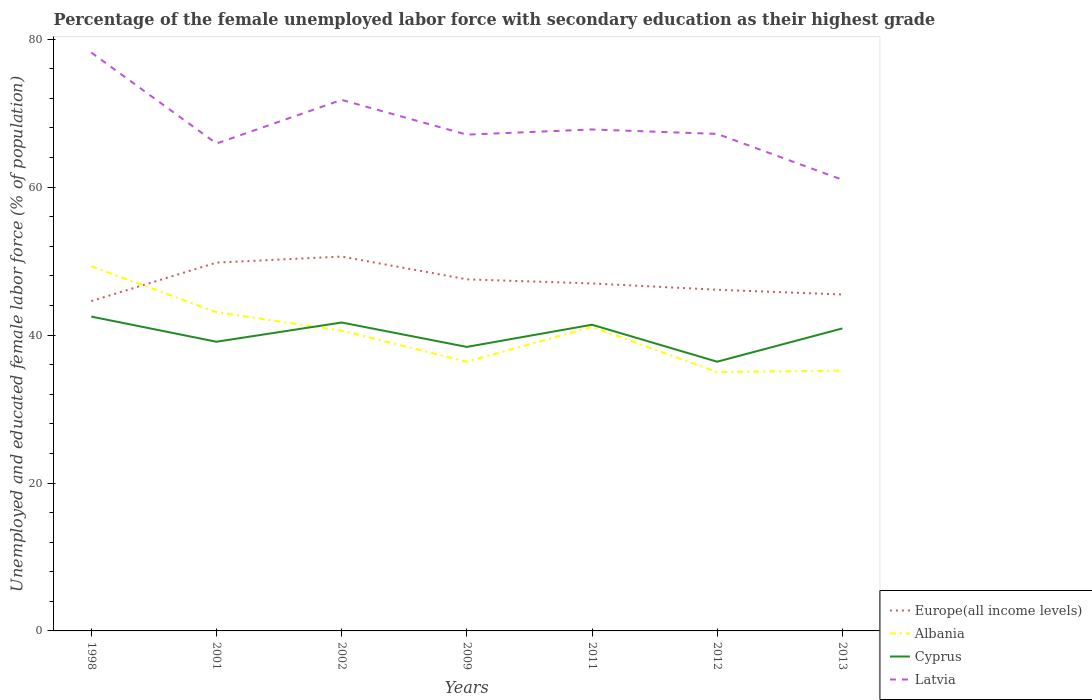How many different coloured lines are there?
Give a very brief answer. 4. Does the line corresponding to Cyprus intersect with the line corresponding to Latvia?
Keep it short and to the point. No. Is the number of lines equal to the number of legend labels?
Offer a terse response. Yes. Across all years, what is the maximum percentage of the unemployed female labor force with secondary education in Europe(all income levels)?
Offer a terse response. 44.6. What is the total percentage of the unemployed female labor force with secondary education in Albania in the graph?
Make the answer very short. 8.1. What is the difference between the highest and the second highest percentage of the unemployed female labor force with secondary education in Latvia?
Make the answer very short. 17.2. What is the difference between the highest and the lowest percentage of the unemployed female labor force with secondary education in Latvia?
Provide a short and direct response. 2. Does the graph contain grids?
Your answer should be very brief. No. How many legend labels are there?
Ensure brevity in your answer.  4. How are the legend labels stacked?
Your answer should be very brief. Vertical. What is the title of the graph?
Provide a short and direct response. Percentage of the female unemployed labor force with secondary education as their highest grade. Does "San Marino" appear as one of the legend labels in the graph?
Your answer should be compact. No. What is the label or title of the Y-axis?
Your response must be concise. Unemployed and educated female labor force (% of population). What is the Unemployed and educated female labor force (% of population) of Europe(all income levels) in 1998?
Your response must be concise. 44.6. What is the Unemployed and educated female labor force (% of population) of Albania in 1998?
Give a very brief answer. 49.3. What is the Unemployed and educated female labor force (% of population) of Cyprus in 1998?
Your answer should be compact. 42.5. What is the Unemployed and educated female labor force (% of population) of Latvia in 1998?
Provide a short and direct response. 78.2. What is the Unemployed and educated female labor force (% of population) in Europe(all income levels) in 2001?
Provide a short and direct response. 49.8. What is the Unemployed and educated female labor force (% of population) in Albania in 2001?
Keep it short and to the point. 43.1. What is the Unemployed and educated female labor force (% of population) in Cyprus in 2001?
Give a very brief answer. 39.1. What is the Unemployed and educated female labor force (% of population) in Latvia in 2001?
Provide a succinct answer. 65.9. What is the Unemployed and educated female labor force (% of population) in Europe(all income levels) in 2002?
Provide a short and direct response. 50.62. What is the Unemployed and educated female labor force (% of population) in Albania in 2002?
Make the answer very short. 40.6. What is the Unemployed and educated female labor force (% of population) of Cyprus in 2002?
Offer a very short reply. 41.7. What is the Unemployed and educated female labor force (% of population) in Latvia in 2002?
Ensure brevity in your answer.  71.8. What is the Unemployed and educated female labor force (% of population) of Europe(all income levels) in 2009?
Your response must be concise. 47.54. What is the Unemployed and educated female labor force (% of population) in Albania in 2009?
Give a very brief answer. 36.4. What is the Unemployed and educated female labor force (% of population) of Cyprus in 2009?
Provide a succinct answer. 38.4. What is the Unemployed and educated female labor force (% of population) in Latvia in 2009?
Give a very brief answer. 67.1. What is the Unemployed and educated female labor force (% of population) in Europe(all income levels) in 2011?
Your answer should be compact. 46.98. What is the Unemployed and educated female labor force (% of population) in Albania in 2011?
Your answer should be compact. 41.1. What is the Unemployed and educated female labor force (% of population) of Cyprus in 2011?
Offer a terse response. 41.4. What is the Unemployed and educated female labor force (% of population) of Latvia in 2011?
Keep it short and to the point. 67.8. What is the Unemployed and educated female labor force (% of population) in Europe(all income levels) in 2012?
Keep it short and to the point. 46.13. What is the Unemployed and educated female labor force (% of population) in Albania in 2012?
Offer a very short reply. 35. What is the Unemployed and educated female labor force (% of population) of Cyprus in 2012?
Provide a succinct answer. 36.4. What is the Unemployed and educated female labor force (% of population) of Latvia in 2012?
Your answer should be compact. 67.2. What is the Unemployed and educated female labor force (% of population) of Europe(all income levels) in 2013?
Your answer should be very brief. 45.49. What is the Unemployed and educated female labor force (% of population) of Albania in 2013?
Offer a terse response. 35.2. What is the Unemployed and educated female labor force (% of population) of Cyprus in 2013?
Your response must be concise. 40.9. Across all years, what is the maximum Unemployed and educated female labor force (% of population) of Europe(all income levels)?
Make the answer very short. 50.62. Across all years, what is the maximum Unemployed and educated female labor force (% of population) of Albania?
Keep it short and to the point. 49.3. Across all years, what is the maximum Unemployed and educated female labor force (% of population) in Cyprus?
Your response must be concise. 42.5. Across all years, what is the maximum Unemployed and educated female labor force (% of population) in Latvia?
Your answer should be compact. 78.2. Across all years, what is the minimum Unemployed and educated female labor force (% of population) in Europe(all income levels)?
Offer a terse response. 44.6. Across all years, what is the minimum Unemployed and educated female labor force (% of population) in Albania?
Keep it short and to the point. 35. Across all years, what is the minimum Unemployed and educated female labor force (% of population) in Cyprus?
Provide a succinct answer. 36.4. What is the total Unemployed and educated female labor force (% of population) in Europe(all income levels) in the graph?
Give a very brief answer. 331.15. What is the total Unemployed and educated female labor force (% of population) in Albania in the graph?
Make the answer very short. 280.7. What is the total Unemployed and educated female labor force (% of population) of Cyprus in the graph?
Give a very brief answer. 280.4. What is the total Unemployed and educated female labor force (% of population) in Latvia in the graph?
Ensure brevity in your answer.  479. What is the difference between the Unemployed and educated female labor force (% of population) in Europe(all income levels) in 1998 and that in 2001?
Give a very brief answer. -5.2. What is the difference between the Unemployed and educated female labor force (% of population) of Latvia in 1998 and that in 2001?
Give a very brief answer. 12.3. What is the difference between the Unemployed and educated female labor force (% of population) in Europe(all income levels) in 1998 and that in 2002?
Give a very brief answer. -6.02. What is the difference between the Unemployed and educated female labor force (% of population) in Cyprus in 1998 and that in 2002?
Provide a short and direct response. 0.8. What is the difference between the Unemployed and educated female labor force (% of population) in Europe(all income levels) in 1998 and that in 2009?
Your response must be concise. -2.94. What is the difference between the Unemployed and educated female labor force (% of population) of Albania in 1998 and that in 2009?
Offer a terse response. 12.9. What is the difference between the Unemployed and educated female labor force (% of population) of Europe(all income levels) in 1998 and that in 2011?
Give a very brief answer. -2.38. What is the difference between the Unemployed and educated female labor force (% of population) in Europe(all income levels) in 1998 and that in 2012?
Ensure brevity in your answer.  -1.53. What is the difference between the Unemployed and educated female labor force (% of population) of Cyprus in 1998 and that in 2012?
Your answer should be very brief. 6.1. What is the difference between the Unemployed and educated female labor force (% of population) of Europe(all income levels) in 1998 and that in 2013?
Your response must be concise. -0.89. What is the difference between the Unemployed and educated female labor force (% of population) of Latvia in 1998 and that in 2013?
Offer a very short reply. 17.2. What is the difference between the Unemployed and educated female labor force (% of population) in Europe(all income levels) in 2001 and that in 2002?
Provide a short and direct response. -0.82. What is the difference between the Unemployed and educated female labor force (% of population) of Albania in 2001 and that in 2002?
Make the answer very short. 2.5. What is the difference between the Unemployed and educated female labor force (% of population) in Europe(all income levels) in 2001 and that in 2009?
Keep it short and to the point. 2.26. What is the difference between the Unemployed and educated female labor force (% of population) of Albania in 2001 and that in 2009?
Provide a short and direct response. 6.7. What is the difference between the Unemployed and educated female labor force (% of population) in Latvia in 2001 and that in 2009?
Ensure brevity in your answer.  -1.2. What is the difference between the Unemployed and educated female labor force (% of population) in Europe(all income levels) in 2001 and that in 2011?
Offer a very short reply. 2.82. What is the difference between the Unemployed and educated female labor force (% of population) in Latvia in 2001 and that in 2011?
Your answer should be compact. -1.9. What is the difference between the Unemployed and educated female labor force (% of population) of Europe(all income levels) in 2001 and that in 2012?
Keep it short and to the point. 3.67. What is the difference between the Unemployed and educated female labor force (% of population) of Albania in 2001 and that in 2012?
Ensure brevity in your answer.  8.1. What is the difference between the Unemployed and educated female labor force (% of population) of Europe(all income levels) in 2001 and that in 2013?
Your response must be concise. 4.31. What is the difference between the Unemployed and educated female labor force (% of population) in Latvia in 2001 and that in 2013?
Keep it short and to the point. 4.9. What is the difference between the Unemployed and educated female labor force (% of population) of Europe(all income levels) in 2002 and that in 2009?
Provide a short and direct response. 3.08. What is the difference between the Unemployed and educated female labor force (% of population) of Latvia in 2002 and that in 2009?
Provide a short and direct response. 4.7. What is the difference between the Unemployed and educated female labor force (% of population) in Europe(all income levels) in 2002 and that in 2011?
Provide a short and direct response. 3.64. What is the difference between the Unemployed and educated female labor force (% of population) in Albania in 2002 and that in 2011?
Provide a short and direct response. -0.5. What is the difference between the Unemployed and educated female labor force (% of population) in Latvia in 2002 and that in 2011?
Keep it short and to the point. 4. What is the difference between the Unemployed and educated female labor force (% of population) of Europe(all income levels) in 2002 and that in 2012?
Keep it short and to the point. 4.49. What is the difference between the Unemployed and educated female labor force (% of population) of Albania in 2002 and that in 2012?
Offer a terse response. 5.6. What is the difference between the Unemployed and educated female labor force (% of population) in Latvia in 2002 and that in 2012?
Offer a terse response. 4.6. What is the difference between the Unemployed and educated female labor force (% of population) in Europe(all income levels) in 2002 and that in 2013?
Offer a terse response. 5.13. What is the difference between the Unemployed and educated female labor force (% of population) of Cyprus in 2002 and that in 2013?
Provide a succinct answer. 0.8. What is the difference between the Unemployed and educated female labor force (% of population) of Europe(all income levels) in 2009 and that in 2011?
Your answer should be very brief. 0.56. What is the difference between the Unemployed and educated female labor force (% of population) of Cyprus in 2009 and that in 2011?
Ensure brevity in your answer.  -3. What is the difference between the Unemployed and educated female labor force (% of population) in Latvia in 2009 and that in 2011?
Ensure brevity in your answer.  -0.7. What is the difference between the Unemployed and educated female labor force (% of population) of Europe(all income levels) in 2009 and that in 2012?
Offer a terse response. 1.41. What is the difference between the Unemployed and educated female labor force (% of population) in Albania in 2009 and that in 2012?
Give a very brief answer. 1.4. What is the difference between the Unemployed and educated female labor force (% of population) in Cyprus in 2009 and that in 2012?
Your answer should be compact. 2. What is the difference between the Unemployed and educated female labor force (% of population) in Europe(all income levels) in 2009 and that in 2013?
Provide a short and direct response. 2.05. What is the difference between the Unemployed and educated female labor force (% of population) of Albania in 2009 and that in 2013?
Offer a terse response. 1.2. What is the difference between the Unemployed and educated female labor force (% of population) in Cyprus in 2009 and that in 2013?
Provide a succinct answer. -2.5. What is the difference between the Unemployed and educated female labor force (% of population) of Latvia in 2009 and that in 2013?
Offer a very short reply. 6.1. What is the difference between the Unemployed and educated female labor force (% of population) in Europe(all income levels) in 2011 and that in 2012?
Your answer should be compact. 0.85. What is the difference between the Unemployed and educated female labor force (% of population) of Albania in 2011 and that in 2012?
Your answer should be very brief. 6.1. What is the difference between the Unemployed and educated female labor force (% of population) of Europe(all income levels) in 2011 and that in 2013?
Your response must be concise. 1.49. What is the difference between the Unemployed and educated female labor force (% of population) in Cyprus in 2011 and that in 2013?
Provide a succinct answer. 0.5. What is the difference between the Unemployed and educated female labor force (% of population) in Europe(all income levels) in 2012 and that in 2013?
Ensure brevity in your answer.  0.64. What is the difference between the Unemployed and educated female labor force (% of population) in Albania in 2012 and that in 2013?
Ensure brevity in your answer.  -0.2. What is the difference between the Unemployed and educated female labor force (% of population) in Cyprus in 2012 and that in 2013?
Keep it short and to the point. -4.5. What is the difference between the Unemployed and educated female labor force (% of population) in Latvia in 2012 and that in 2013?
Provide a succinct answer. 6.2. What is the difference between the Unemployed and educated female labor force (% of population) of Europe(all income levels) in 1998 and the Unemployed and educated female labor force (% of population) of Albania in 2001?
Offer a terse response. 1.5. What is the difference between the Unemployed and educated female labor force (% of population) in Europe(all income levels) in 1998 and the Unemployed and educated female labor force (% of population) in Cyprus in 2001?
Give a very brief answer. 5.5. What is the difference between the Unemployed and educated female labor force (% of population) of Europe(all income levels) in 1998 and the Unemployed and educated female labor force (% of population) of Latvia in 2001?
Offer a terse response. -21.3. What is the difference between the Unemployed and educated female labor force (% of population) of Albania in 1998 and the Unemployed and educated female labor force (% of population) of Latvia in 2001?
Provide a short and direct response. -16.6. What is the difference between the Unemployed and educated female labor force (% of population) in Cyprus in 1998 and the Unemployed and educated female labor force (% of population) in Latvia in 2001?
Offer a very short reply. -23.4. What is the difference between the Unemployed and educated female labor force (% of population) in Europe(all income levels) in 1998 and the Unemployed and educated female labor force (% of population) in Albania in 2002?
Your answer should be compact. 4. What is the difference between the Unemployed and educated female labor force (% of population) of Europe(all income levels) in 1998 and the Unemployed and educated female labor force (% of population) of Cyprus in 2002?
Make the answer very short. 2.9. What is the difference between the Unemployed and educated female labor force (% of population) in Europe(all income levels) in 1998 and the Unemployed and educated female labor force (% of population) in Latvia in 2002?
Offer a terse response. -27.2. What is the difference between the Unemployed and educated female labor force (% of population) of Albania in 1998 and the Unemployed and educated female labor force (% of population) of Cyprus in 2002?
Offer a very short reply. 7.6. What is the difference between the Unemployed and educated female labor force (% of population) of Albania in 1998 and the Unemployed and educated female labor force (% of population) of Latvia in 2002?
Offer a very short reply. -22.5. What is the difference between the Unemployed and educated female labor force (% of population) of Cyprus in 1998 and the Unemployed and educated female labor force (% of population) of Latvia in 2002?
Offer a very short reply. -29.3. What is the difference between the Unemployed and educated female labor force (% of population) in Europe(all income levels) in 1998 and the Unemployed and educated female labor force (% of population) in Albania in 2009?
Provide a succinct answer. 8.2. What is the difference between the Unemployed and educated female labor force (% of population) in Europe(all income levels) in 1998 and the Unemployed and educated female labor force (% of population) in Cyprus in 2009?
Make the answer very short. 6.2. What is the difference between the Unemployed and educated female labor force (% of population) in Europe(all income levels) in 1998 and the Unemployed and educated female labor force (% of population) in Latvia in 2009?
Keep it short and to the point. -22.5. What is the difference between the Unemployed and educated female labor force (% of population) of Albania in 1998 and the Unemployed and educated female labor force (% of population) of Cyprus in 2009?
Your response must be concise. 10.9. What is the difference between the Unemployed and educated female labor force (% of population) of Albania in 1998 and the Unemployed and educated female labor force (% of population) of Latvia in 2009?
Ensure brevity in your answer.  -17.8. What is the difference between the Unemployed and educated female labor force (% of population) of Cyprus in 1998 and the Unemployed and educated female labor force (% of population) of Latvia in 2009?
Offer a terse response. -24.6. What is the difference between the Unemployed and educated female labor force (% of population) of Europe(all income levels) in 1998 and the Unemployed and educated female labor force (% of population) of Albania in 2011?
Your answer should be compact. 3.5. What is the difference between the Unemployed and educated female labor force (% of population) in Europe(all income levels) in 1998 and the Unemployed and educated female labor force (% of population) in Cyprus in 2011?
Provide a succinct answer. 3.2. What is the difference between the Unemployed and educated female labor force (% of population) of Europe(all income levels) in 1998 and the Unemployed and educated female labor force (% of population) of Latvia in 2011?
Your response must be concise. -23.2. What is the difference between the Unemployed and educated female labor force (% of population) of Albania in 1998 and the Unemployed and educated female labor force (% of population) of Latvia in 2011?
Give a very brief answer. -18.5. What is the difference between the Unemployed and educated female labor force (% of population) in Cyprus in 1998 and the Unemployed and educated female labor force (% of population) in Latvia in 2011?
Your answer should be very brief. -25.3. What is the difference between the Unemployed and educated female labor force (% of population) of Europe(all income levels) in 1998 and the Unemployed and educated female labor force (% of population) of Albania in 2012?
Provide a short and direct response. 9.6. What is the difference between the Unemployed and educated female labor force (% of population) of Europe(all income levels) in 1998 and the Unemployed and educated female labor force (% of population) of Cyprus in 2012?
Provide a succinct answer. 8.2. What is the difference between the Unemployed and educated female labor force (% of population) in Europe(all income levels) in 1998 and the Unemployed and educated female labor force (% of population) in Latvia in 2012?
Offer a terse response. -22.6. What is the difference between the Unemployed and educated female labor force (% of population) of Albania in 1998 and the Unemployed and educated female labor force (% of population) of Latvia in 2012?
Offer a terse response. -17.9. What is the difference between the Unemployed and educated female labor force (% of population) of Cyprus in 1998 and the Unemployed and educated female labor force (% of population) of Latvia in 2012?
Offer a very short reply. -24.7. What is the difference between the Unemployed and educated female labor force (% of population) of Europe(all income levels) in 1998 and the Unemployed and educated female labor force (% of population) of Albania in 2013?
Provide a short and direct response. 9.4. What is the difference between the Unemployed and educated female labor force (% of population) of Europe(all income levels) in 1998 and the Unemployed and educated female labor force (% of population) of Cyprus in 2013?
Offer a terse response. 3.7. What is the difference between the Unemployed and educated female labor force (% of population) in Europe(all income levels) in 1998 and the Unemployed and educated female labor force (% of population) in Latvia in 2013?
Offer a terse response. -16.4. What is the difference between the Unemployed and educated female labor force (% of population) of Albania in 1998 and the Unemployed and educated female labor force (% of population) of Cyprus in 2013?
Your answer should be compact. 8.4. What is the difference between the Unemployed and educated female labor force (% of population) of Albania in 1998 and the Unemployed and educated female labor force (% of population) of Latvia in 2013?
Offer a very short reply. -11.7. What is the difference between the Unemployed and educated female labor force (% of population) of Cyprus in 1998 and the Unemployed and educated female labor force (% of population) of Latvia in 2013?
Keep it short and to the point. -18.5. What is the difference between the Unemployed and educated female labor force (% of population) in Europe(all income levels) in 2001 and the Unemployed and educated female labor force (% of population) in Albania in 2002?
Keep it short and to the point. 9.2. What is the difference between the Unemployed and educated female labor force (% of population) in Europe(all income levels) in 2001 and the Unemployed and educated female labor force (% of population) in Cyprus in 2002?
Offer a very short reply. 8.1. What is the difference between the Unemployed and educated female labor force (% of population) of Europe(all income levels) in 2001 and the Unemployed and educated female labor force (% of population) of Latvia in 2002?
Offer a terse response. -22. What is the difference between the Unemployed and educated female labor force (% of population) in Albania in 2001 and the Unemployed and educated female labor force (% of population) in Latvia in 2002?
Your response must be concise. -28.7. What is the difference between the Unemployed and educated female labor force (% of population) in Cyprus in 2001 and the Unemployed and educated female labor force (% of population) in Latvia in 2002?
Provide a succinct answer. -32.7. What is the difference between the Unemployed and educated female labor force (% of population) of Europe(all income levels) in 2001 and the Unemployed and educated female labor force (% of population) of Albania in 2009?
Ensure brevity in your answer.  13.4. What is the difference between the Unemployed and educated female labor force (% of population) of Europe(all income levels) in 2001 and the Unemployed and educated female labor force (% of population) of Cyprus in 2009?
Keep it short and to the point. 11.4. What is the difference between the Unemployed and educated female labor force (% of population) of Europe(all income levels) in 2001 and the Unemployed and educated female labor force (% of population) of Latvia in 2009?
Make the answer very short. -17.3. What is the difference between the Unemployed and educated female labor force (% of population) of Albania in 2001 and the Unemployed and educated female labor force (% of population) of Cyprus in 2009?
Offer a terse response. 4.7. What is the difference between the Unemployed and educated female labor force (% of population) of Cyprus in 2001 and the Unemployed and educated female labor force (% of population) of Latvia in 2009?
Make the answer very short. -28. What is the difference between the Unemployed and educated female labor force (% of population) of Europe(all income levels) in 2001 and the Unemployed and educated female labor force (% of population) of Albania in 2011?
Your answer should be compact. 8.7. What is the difference between the Unemployed and educated female labor force (% of population) in Europe(all income levels) in 2001 and the Unemployed and educated female labor force (% of population) in Cyprus in 2011?
Your response must be concise. 8.4. What is the difference between the Unemployed and educated female labor force (% of population) of Europe(all income levels) in 2001 and the Unemployed and educated female labor force (% of population) of Latvia in 2011?
Provide a short and direct response. -18. What is the difference between the Unemployed and educated female labor force (% of population) of Albania in 2001 and the Unemployed and educated female labor force (% of population) of Cyprus in 2011?
Provide a succinct answer. 1.7. What is the difference between the Unemployed and educated female labor force (% of population) of Albania in 2001 and the Unemployed and educated female labor force (% of population) of Latvia in 2011?
Your response must be concise. -24.7. What is the difference between the Unemployed and educated female labor force (% of population) in Cyprus in 2001 and the Unemployed and educated female labor force (% of population) in Latvia in 2011?
Your answer should be compact. -28.7. What is the difference between the Unemployed and educated female labor force (% of population) in Europe(all income levels) in 2001 and the Unemployed and educated female labor force (% of population) in Albania in 2012?
Offer a very short reply. 14.8. What is the difference between the Unemployed and educated female labor force (% of population) in Europe(all income levels) in 2001 and the Unemployed and educated female labor force (% of population) in Cyprus in 2012?
Your answer should be compact. 13.4. What is the difference between the Unemployed and educated female labor force (% of population) of Europe(all income levels) in 2001 and the Unemployed and educated female labor force (% of population) of Latvia in 2012?
Give a very brief answer. -17.4. What is the difference between the Unemployed and educated female labor force (% of population) of Albania in 2001 and the Unemployed and educated female labor force (% of population) of Cyprus in 2012?
Offer a terse response. 6.7. What is the difference between the Unemployed and educated female labor force (% of population) of Albania in 2001 and the Unemployed and educated female labor force (% of population) of Latvia in 2012?
Give a very brief answer. -24.1. What is the difference between the Unemployed and educated female labor force (% of population) in Cyprus in 2001 and the Unemployed and educated female labor force (% of population) in Latvia in 2012?
Your answer should be compact. -28.1. What is the difference between the Unemployed and educated female labor force (% of population) in Europe(all income levels) in 2001 and the Unemployed and educated female labor force (% of population) in Albania in 2013?
Keep it short and to the point. 14.6. What is the difference between the Unemployed and educated female labor force (% of population) in Europe(all income levels) in 2001 and the Unemployed and educated female labor force (% of population) in Cyprus in 2013?
Offer a very short reply. 8.9. What is the difference between the Unemployed and educated female labor force (% of population) of Europe(all income levels) in 2001 and the Unemployed and educated female labor force (% of population) of Latvia in 2013?
Make the answer very short. -11.2. What is the difference between the Unemployed and educated female labor force (% of population) of Albania in 2001 and the Unemployed and educated female labor force (% of population) of Latvia in 2013?
Give a very brief answer. -17.9. What is the difference between the Unemployed and educated female labor force (% of population) of Cyprus in 2001 and the Unemployed and educated female labor force (% of population) of Latvia in 2013?
Give a very brief answer. -21.9. What is the difference between the Unemployed and educated female labor force (% of population) of Europe(all income levels) in 2002 and the Unemployed and educated female labor force (% of population) of Albania in 2009?
Provide a succinct answer. 14.22. What is the difference between the Unemployed and educated female labor force (% of population) in Europe(all income levels) in 2002 and the Unemployed and educated female labor force (% of population) in Cyprus in 2009?
Give a very brief answer. 12.22. What is the difference between the Unemployed and educated female labor force (% of population) of Europe(all income levels) in 2002 and the Unemployed and educated female labor force (% of population) of Latvia in 2009?
Offer a terse response. -16.48. What is the difference between the Unemployed and educated female labor force (% of population) in Albania in 2002 and the Unemployed and educated female labor force (% of population) in Latvia in 2009?
Your response must be concise. -26.5. What is the difference between the Unemployed and educated female labor force (% of population) of Cyprus in 2002 and the Unemployed and educated female labor force (% of population) of Latvia in 2009?
Make the answer very short. -25.4. What is the difference between the Unemployed and educated female labor force (% of population) of Europe(all income levels) in 2002 and the Unemployed and educated female labor force (% of population) of Albania in 2011?
Offer a terse response. 9.52. What is the difference between the Unemployed and educated female labor force (% of population) in Europe(all income levels) in 2002 and the Unemployed and educated female labor force (% of population) in Cyprus in 2011?
Your answer should be compact. 9.22. What is the difference between the Unemployed and educated female labor force (% of population) in Europe(all income levels) in 2002 and the Unemployed and educated female labor force (% of population) in Latvia in 2011?
Your answer should be very brief. -17.18. What is the difference between the Unemployed and educated female labor force (% of population) of Albania in 2002 and the Unemployed and educated female labor force (% of population) of Latvia in 2011?
Make the answer very short. -27.2. What is the difference between the Unemployed and educated female labor force (% of population) in Cyprus in 2002 and the Unemployed and educated female labor force (% of population) in Latvia in 2011?
Offer a very short reply. -26.1. What is the difference between the Unemployed and educated female labor force (% of population) in Europe(all income levels) in 2002 and the Unemployed and educated female labor force (% of population) in Albania in 2012?
Keep it short and to the point. 15.62. What is the difference between the Unemployed and educated female labor force (% of population) of Europe(all income levels) in 2002 and the Unemployed and educated female labor force (% of population) of Cyprus in 2012?
Your answer should be very brief. 14.22. What is the difference between the Unemployed and educated female labor force (% of population) of Europe(all income levels) in 2002 and the Unemployed and educated female labor force (% of population) of Latvia in 2012?
Make the answer very short. -16.58. What is the difference between the Unemployed and educated female labor force (% of population) of Albania in 2002 and the Unemployed and educated female labor force (% of population) of Cyprus in 2012?
Make the answer very short. 4.2. What is the difference between the Unemployed and educated female labor force (% of population) in Albania in 2002 and the Unemployed and educated female labor force (% of population) in Latvia in 2012?
Provide a succinct answer. -26.6. What is the difference between the Unemployed and educated female labor force (% of population) in Cyprus in 2002 and the Unemployed and educated female labor force (% of population) in Latvia in 2012?
Your answer should be compact. -25.5. What is the difference between the Unemployed and educated female labor force (% of population) of Europe(all income levels) in 2002 and the Unemployed and educated female labor force (% of population) of Albania in 2013?
Offer a terse response. 15.42. What is the difference between the Unemployed and educated female labor force (% of population) of Europe(all income levels) in 2002 and the Unemployed and educated female labor force (% of population) of Cyprus in 2013?
Offer a terse response. 9.72. What is the difference between the Unemployed and educated female labor force (% of population) of Europe(all income levels) in 2002 and the Unemployed and educated female labor force (% of population) of Latvia in 2013?
Keep it short and to the point. -10.38. What is the difference between the Unemployed and educated female labor force (% of population) of Albania in 2002 and the Unemployed and educated female labor force (% of population) of Cyprus in 2013?
Offer a very short reply. -0.3. What is the difference between the Unemployed and educated female labor force (% of population) in Albania in 2002 and the Unemployed and educated female labor force (% of population) in Latvia in 2013?
Keep it short and to the point. -20.4. What is the difference between the Unemployed and educated female labor force (% of population) of Cyprus in 2002 and the Unemployed and educated female labor force (% of population) of Latvia in 2013?
Your response must be concise. -19.3. What is the difference between the Unemployed and educated female labor force (% of population) in Europe(all income levels) in 2009 and the Unemployed and educated female labor force (% of population) in Albania in 2011?
Ensure brevity in your answer.  6.44. What is the difference between the Unemployed and educated female labor force (% of population) of Europe(all income levels) in 2009 and the Unemployed and educated female labor force (% of population) of Cyprus in 2011?
Offer a terse response. 6.14. What is the difference between the Unemployed and educated female labor force (% of population) in Europe(all income levels) in 2009 and the Unemployed and educated female labor force (% of population) in Latvia in 2011?
Provide a short and direct response. -20.26. What is the difference between the Unemployed and educated female labor force (% of population) of Albania in 2009 and the Unemployed and educated female labor force (% of population) of Latvia in 2011?
Your answer should be very brief. -31.4. What is the difference between the Unemployed and educated female labor force (% of population) of Cyprus in 2009 and the Unemployed and educated female labor force (% of population) of Latvia in 2011?
Ensure brevity in your answer.  -29.4. What is the difference between the Unemployed and educated female labor force (% of population) in Europe(all income levels) in 2009 and the Unemployed and educated female labor force (% of population) in Albania in 2012?
Give a very brief answer. 12.54. What is the difference between the Unemployed and educated female labor force (% of population) in Europe(all income levels) in 2009 and the Unemployed and educated female labor force (% of population) in Cyprus in 2012?
Your answer should be compact. 11.14. What is the difference between the Unemployed and educated female labor force (% of population) of Europe(all income levels) in 2009 and the Unemployed and educated female labor force (% of population) of Latvia in 2012?
Offer a terse response. -19.66. What is the difference between the Unemployed and educated female labor force (% of population) in Albania in 2009 and the Unemployed and educated female labor force (% of population) in Latvia in 2012?
Give a very brief answer. -30.8. What is the difference between the Unemployed and educated female labor force (% of population) of Cyprus in 2009 and the Unemployed and educated female labor force (% of population) of Latvia in 2012?
Offer a terse response. -28.8. What is the difference between the Unemployed and educated female labor force (% of population) of Europe(all income levels) in 2009 and the Unemployed and educated female labor force (% of population) of Albania in 2013?
Ensure brevity in your answer.  12.34. What is the difference between the Unemployed and educated female labor force (% of population) in Europe(all income levels) in 2009 and the Unemployed and educated female labor force (% of population) in Cyprus in 2013?
Ensure brevity in your answer.  6.64. What is the difference between the Unemployed and educated female labor force (% of population) in Europe(all income levels) in 2009 and the Unemployed and educated female labor force (% of population) in Latvia in 2013?
Your response must be concise. -13.46. What is the difference between the Unemployed and educated female labor force (% of population) in Albania in 2009 and the Unemployed and educated female labor force (% of population) in Cyprus in 2013?
Offer a terse response. -4.5. What is the difference between the Unemployed and educated female labor force (% of population) of Albania in 2009 and the Unemployed and educated female labor force (% of population) of Latvia in 2013?
Give a very brief answer. -24.6. What is the difference between the Unemployed and educated female labor force (% of population) of Cyprus in 2009 and the Unemployed and educated female labor force (% of population) of Latvia in 2013?
Give a very brief answer. -22.6. What is the difference between the Unemployed and educated female labor force (% of population) in Europe(all income levels) in 2011 and the Unemployed and educated female labor force (% of population) in Albania in 2012?
Provide a short and direct response. 11.98. What is the difference between the Unemployed and educated female labor force (% of population) in Europe(all income levels) in 2011 and the Unemployed and educated female labor force (% of population) in Cyprus in 2012?
Your response must be concise. 10.58. What is the difference between the Unemployed and educated female labor force (% of population) of Europe(all income levels) in 2011 and the Unemployed and educated female labor force (% of population) of Latvia in 2012?
Provide a succinct answer. -20.22. What is the difference between the Unemployed and educated female labor force (% of population) of Albania in 2011 and the Unemployed and educated female labor force (% of population) of Latvia in 2012?
Provide a short and direct response. -26.1. What is the difference between the Unemployed and educated female labor force (% of population) of Cyprus in 2011 and the Unemployed and educated female labor force (% of population) of Latvia in 2012?
Your answer should be very brief. -25.8. What is the difference between the Unemployed and educated female labor force (% of population) in Europe(all income levels) in 2011 and the Unemployed and educated female labor force (% of population) in Albania in 2013?
Give a very brief answer. 11.78. What is the difference between the Unemployed and educated female labor force (% of population) in Europe(all income levels) in 2011 and the Unemployed and educated female labor force (% of population) in Cyprus in 2013?
Your answer should be very brief. 6.08. What is the difference between the Unemployed and educated female labor force (% of population) of Europe(all income levels) in 2011 and the Unemployed and educated female labor force (% of population) of Latvia in 2013?
Your answer should be compact. -14.02. What is the difference between the Unemployed and educated female labor force (% of population) of Albania in 2011 and the Unemployed and educated female labor force (% of population) of Latvia in 2013?
Your response must be concise. -19.9. What is the difference between the Unemployed and educated female labor force (% of population) in Cyprus in 2011 and the Unemployed and educated female labor force (% of population) in Latvia in 2013?
Keep it short and to the point. -19.6. What is the difference between the Unemployed and educated female labor force (% of population) of Europe(all income levels) in 2012 and the Unemployed and educated female labor force (% of population) of Albania in 2013?
Offer a terse response. 10.93. What is the difference between the Unemployed and educated female labor force (% of population) of Europe(all income levels) in 2012 and the Unemployed and educated female labor force (% of population) of Cyprus in 2013?
Keep it short and to the point. 5.23. What is the difference between the Unemployed and educated female labor force (% of population) of Europe(all income levels) in 2012 and the Unemployed and educated female labor force (% of population) of Latvia in 2013?
Provide a short and direct response. -14.87. What is the difference between the Unemployed and educated female labor force (% of population) of Cyprus in 2012 and the Unemployed and educated female labor force (% of population) of Latvia in 2013?
Ensure brevity in your answer.  -24.6. What is the average Unemployed and educated female labor force (% of population) in Europe(all income levels) per year?
Your answer should be compact. 47.31. What is the average Unemployed and educated female labor force (% of population) in Albania per year?
Your answer should be compact. 40.1. What is the average Unemployed and educated female labor force (% of population) of Cyprus per year?
Your answer should be compact. 40.06. What is the average Unemployed and educated female labor force (% of population) of Latvia per year?
Give a very brief answer. 68.43. In the year 1998, what is the difference between the Unemployed and educated female labor force (% of population) in Europe(all income levels) and Unemployed and educated female labor force (% of population) in Albania?
Offer a terse response. -4.7. In the year 1998, what is the difference between the Unemployed and educated female labor force (% of population) in Europe(all income levels) and Unemployed and educated female labor force (% of population) in Cyprus?
Provide a succinct answer. 2.1. In the year 1998, what is the difference between the Unemployed and educated female labor force (% of population) in Europe(all income levels) and Unemployed and educated female labor force (% of population) in Latvia?
Your answer should be compact. -33.6. In the year 1998, what is the difference between the Unemployed and educated female labor force (% of population) in Albania and Unemployed and educated female labor force (% of population) in Cyprus?
Offer a terse response. 6.8. In the year 1998, what is the difference between the Unemployed and educated female labor force (% of population) of Albania and Unemployed and educated female labor force (% of population) of Latvia?
Your answer should be very brief. -28.9. In the year 1998, what is the difference between the Unemployed and educated female labor force (% of population) in Cyprus and Unemployed and educated female labor force (% of population) in Latvia?
Offer a terse response. -35.7. In the year 2001, what is the difference between the Unemployed and educated female labor force (% of population) in Europe(all income levels) and Unemployed and educated female labor force (% of population) in Albania?
Give a very brief answer. 6.7. In the year 2001, what is the difference between the Unemployed and educated female labor force (% of population) in Europe(all income levels) and Unemployed and educated female labor force (% of population) in Cyprus?
Offer a terse response. 10.7. In the year 2001, what is the difference between the Unemployed and educated female labor force (% of population) of Europe(all income levels) and Unemployed and educated female labor force (% of population) of Latvia?
Give a very brief answer. -16.1. In the year 2001, what is the difference between the Unemployed and educated female labor force (% of population) of Albania and Unemployed and educated female labor force (% of population) of Cyprus?
Your answer should be very brief. 4. In the year 2001, what is the difference between the Unemployed and educated female labor force (% of population) of Albania and Unemployed and educated female labor force (% of population) of Latvia?
Your answer should be compact. -22.8. In the year 2001, what is the difference between the Unemployed and educated female labor force (% of population) of Cyprus and Unemployed and educated female labor force (% of population) of Latvia?
Keep it short and to the point. -26.8. In the year 2002, what is the difference between the Unemployed and educated female labor force (% of population) of Europe(all income levels) and Unemployed and educated female labor force (% of population) of Albania?
Make the answer very short. 10.02. In the year 2002, what is the difference between the Unemployed and educated female labor force (% of population) in Europe(all income levels) and Unemployed and educated female labor force (% of population) in Cyprus?
Provide a short and direct response. 8.92. In the year 2002, what is the difference between the Unemployed and educated female labor force (% of population) of Europe(all income levels) and Unemployed and educated female labor force (% of population) of Latvia?
Your response must be concise. -21.18. In the year 2002, what is the difference between the Unemployed and educated female labor force (% of population) in Albania and Unemployed and educated female labor force (% of population) in Cyprus?
Offer a terse response. -1.1. In the year 2002, what is the difference between the Unemployed and educated female labor force (% of population) of Albania and Unemployed and educated female labor force (% of population) of Latvia?
Offer a terse response. -31.2. In the year 2002, what is the difference between the Unemployed and educated female labor force (% of population) of Cyprus and Unemployed and educated female labor force (% of population) of Latvia?
Give a very brief answer. -30.1. In the year 2009, what is the difference between the Unemployed and educated female labor force (% of population) in Europe(all income levels) and Unemployed and educated female labor force (% of population) in Albania?
Ensure brevity in your answer.  11.14. In the year 2009, what is the difference between the Unemployed and educated female labor force (% of population) of Europe(all income levels) and Unemployed and educated female labor force (% of population) of Cyprus?
Offer a terse response. 9.14. In the year 2009, what is the difference between the Unemployed and educated female labor force (% of population) of Europe(all income levels) and Unemployed and educated female labor force (% of population) of Latvia?
Keep it short and to the point. -19.56. In the year 2009, what is the difference between the Unemployed and educated female labor force (% of population) in Albania and Unemployed and educated female labor force (% of population) in Cyprus?
Ensure brevity in your answer.  -2. In the year 2009, what is the difference between the Unemployed and educated female labor force (% of population) of Albania and Unemployed and educated female labor force (% of population) of Latvia?
Ensure brevity in your answer.  -30.7. In the year 2009, what is the difference between the Unemployed and educated female labor force (% of population) in Cyprus and Unemployed and educated female labor force (% of population) in Latvia?
Offer a very short reply. -28.7. In the year 2011, what is the difference between the Unemployed and educated female labor force (% of population) of Europe(all income levels) and Unemployed and educated female labor force (% of population) of Albania?
Provide a succinct answer. 5.88. In the year 2011, what is the difference between the Unemployed and educated female labor force (% of population) in Europe(all income levels) and Unemployed and educated female labor force (% of population) in Cyprus?
Your answer should be compact. 5.58. In the year 2011, what is the difference between the Unemployed and educated female labor force (% of population) of Europe(all income levels) and Unemployed and educated female labor force (% of population) of Latvia?
Keep it short and to the point. -20.82. In the year 2011, what is the difference between the Unemployed and educated female labor force (% of population) of Albania and Unemployed and educated female labor force (% of population) of Latvia?
Your answer should be very brief. -26.7. In the year 2011, what is the difference between the Unemployed and educated female labor force (% of population) of Cyprus and Unemployed and educated female labor force (% of population) of Latvia?
Your response must be concise. -26.4. In the year 2012, what is the difference between the Unemployed and educated female labor force (% of population) of Europe(all income levels) and Unemployed and educated female labor force (% of population) of Albania?
Provide a succinct answer. 11.13. In the year 2012, what is the difference between the Unemployed and educated female labor force (% of population) of Europe(all income levels) and Unemployed and educated female labor force (% of population) of Cyprus?
Give a very brief answer. 9.73. In the year 2012, what is the difference between the Unemployed and educated female labor force (% of population) in Europe(all income levels) and Unemployed and educated female labor force (% of population) in Latvia?
Offer a very short reply. -21.07. In the year 2012, what is the difference between the Unemployed and educated female labor force (% of population) of Albania and Unemployed and educated female labor force (% of population) of Cyprus?
Offer a terse response. -1.4. In the year 2012, what is the difference between the Unemployed and educated female labor force (% of population) in Albania and Unemployed and educated female labor force (% of population) in Latvia?
Offer a terse response. -32.2. In the year 2012, what is the difference between the Unemployed and educated female labor force (% of population) in Cyprus and Unemployed and educated female labor force (% of population) in Latvia?
Your answer should be very brief. -30.8. In the year 2013, what is the difference between the Unemployed and educated female labor force (% of population) of Europe(all income levels) and Unemployed and educated female labor force (% of population) of Albania?
Keep it short and to the point. 10.29. In the year 2013, what is the difference between the Unemployed and educated female labor force (% of population) of Europe(all income levels) and Unemployed and educated female labor force (% of population) of Cyprus?
Provide a short and direct response. 4.59. In the year 2013, what is the difference between the Unemployed and educated female labor force (% of population) in Europe(all income levels) and Unemployed and educated female labor force (% of population) in Latvia?
Your answer should be very brief. -15.51. In the year 2013, what is the difference between the Unemployed and educated female labor force (% of population) of Albania and Unemployed and educated female labor force (% of population) of Latvia?
Your answer should be compact. -25.8. In the year 2013, what is the difference between the Unemployed and educated female labor force (% of population) of Cyprus and Unemployed and educated female labor force (% of population) of Latvia?
Your response must be concise. -20.1. What is the ratio of the Unemployed and educated female labor force (% of population) in Europe(all income levels) in 1998 to that in 2001?
Your answer should be compact. 0.9. What is the ratio of the Unemployed and educated female labor force (% of population) of Albania in 1998 to that in 2001?
Your response must be concise. 1.14. What is the ratio of the Unemployed and educated female labor force (% of population) in Cyprus in 1998 to that in 2001?
Provide a succinct answer. 1.09. What is the ratio of the Unemployed and educated female labor force (% of population) of Latvia in 1998 to that in 2001?
Your response must be concise. 1.19. What is the ratio of the Unemployed and educated female labor force (% of population) of Europe(all income levels) in 1998 to that in 2002?
Offer a very short reply. 0.88. What is the ratio of the Unemployed and educated female labor force (% of population) in Albania in 1998 to that in 2002?
Give a very brief answer. 1.21. What is the ratio of the Unemployed and educated female labor force (% of population) in Cyprus in 1998 to that in 2002?
Keep it short and to the point. 1.02. What is the ratio of the Unemployed and educated female labor force (% of population) in Latvia in 1998 to that in 2002?
Keep it short and to the point. 1.09. What is the ratio of the Unemployed and educated female labor force (% of population) in Europe(all income levels) in 1998 to that in 2009?
Your answer should be compact. 0.94. What is the ratio of the Unemployed and educated female labor force (% of population) of Albania in 1998 to that in 2009?
Provide a succinct answer. 1.35. What is the ratio of the Unemployed and educated female labor force (% of population) in Cyprus in 1998 to that in 2009?
Give a very brief answer. 1.11. What is the ratio of the Unemployed and educated female labor force (% of population) of Latvia in 1998 to that in 2009?
Give a very brief answer. 1.17. What is the ratio of the Unemployed and educated female labor force (% of population) in Europe(all income levels) in 1998 to that in 2011?
Offer a terse response. 0.95. What is the ratio of the Unemployed and educated female labor force (% of population) of Albania in 1998 to that in 2011?
Offer a terse response. 1.2. What is the ratio of the Unemployed and educated female labor force (% of population) of Cyprus in 1998 to that in 2011?
Your answer should be very brief. 1.03. What is the ratio of the Unemployed and educated female labor force (% of population) of Latvia in 1998 to that in 2011?
Provide a succinct answer. 1.15. What is the ratio of the Unemployed and educated female labor force (% of population) of Europe(all income levels) in 1998 to that in 2012?
Offer a very short reply. 0.97. What is the ratio of the Unemployed and educated female labor force (% of population) of Albania in 1998 to that in 2012?
Your answer should be compact. 1.41. What is the ratio of the Unemployed and educated female labor force (% of population) of Cyprus in 1998 to that in 2012?
Provide a short and direct response. 1.17. What is the ratio of the Unemployed and educated female labor force (% of population) of Latvia in 1998 to that in 2012?
Offer a very short reply. 1.16. What is the ratio of the Unemployed and educated female labor force (% of population) in Europe(all income levels) in 1998 to that in 2013?
Your response must be concise. 0.98. What is the ratio of the Unemployed and educated female labor force (% of population) in Albania in 1998 to that in 2013?
Ensure brevity in your answer.  1.4. What is the ratio of the Unemployed and educated female labor force (% of population) in Cyprus in 1998 to that in 2013?
Provide a short and direct response. 1.04. What is the ratio of the Unemployed and educated female labor force (% of population) in Latvia in 1998 to that in 2013?
Keep it short and to the point. 1.28. What is the ratio of the Unemployed and educated female labor force (% of population) of Europe(all income levels) in 2001 to that in 2002?
Provide a short and direct response. 0.98. What is the ratio of the Unemployed and educated female labor force (% of population) in Albania in 2001 to that in 2002?
Ensure brevity in your answer.  1.06. What is the ratio of the Unemployed and educated female labor force (% of population) in Cyprus in 2001 to that in 2002?
Keep it short and to the point. 0.94. What is the ratio of the Unemployed and educated female labor force (% of population) of Latvia in 2001 to that in 2002?
Provide a short and direct response. 0.92. What is the ratio of the Unemployed and educated female labor force (% of population) of Europe(all income levels) in 2001 to that in 2009?
Offer a very short reply. 1.05. What is the ratio of the Unemployed and educated female labor force (% of population) in Albania in 2001 to that in 2009?
Ensure brevity in your answer.  1.18. What is the ratio of the Unemployed and educated female labor force (% of population) of Cyprus in 2001 to that in 2009?
Your response must be concise. 1.02. What is the ratio of the Unemployed and educated female labor force (% of population) in Latvia in 2001 to that in 2009?
Provide a short and direct response. 0.98. What is the ratio of the Unemployed and educated female labor force (% of population) in Europe(all income levels) in 2001 to that in 2011?
Your response must be concise. 1.06. What is the ratio of the Unemployed and educated female labor force (% of population) of Albania in 2001 to that in 2011?
Keep it short and to the point. 1.05. What is the ratio of the Unemployed and educated female labor force (% of population) in Latvia in 2001 to that in 2011?
Offer a very short reply. 0.97. What is the ratio of the Unemployed and educated female labor force (% of population) in Europe(all income levels) in 2001 to that in 2012?
Give a very brief answer. 1.08. What is the ratio of the Unemployed and educated female labor force (% of population) of Albania in 2001 to that in 2012?
Offer a terse response. 1.23. What is the ratio of the Unemployed and educated female labor force (% of population) in Cyprus in 2001 to that in 2012?
Provide a succinct answer. 1.07. What is the ratio of the Unemployed and educated female labor force (% of population) in Latvia in 2001 to that in 2012?
Offer a terse response. 0.98. What is the ratio of the Unemployed and educated female labor force (% of population) of Europe(all income levels) in 2001 to that in 2013?
Provide a succinct answer. 1.09. What is the ratio of the Unemployed and educated female labor force (% of population) of Albania in 2001 to that in 2013?
Your answer should be compact. 1.22. What is the ratio of the Unemployed and educated female labor force (% of population) of Cyprus in 2001 to that in 2013?
Ensure brevity in your answer.  0.96. What is the ratio of the Unemployed and educated female labor force (% of population) of Latvia in 2001 to that in 2013?
Your answer should be compact. 1.08. What is the ratio of the Unemployed and educated female labor force (% of population) in Europe(all income levels) in 2002 to that in 2009?
Your response must be concise. 1.06. What is the ratio of the Unemployed and educated female labor force (% of population) in Albania in 2002 to that in 2009?
Offer a terse response. 1.12. What is the ratio of the Unemployed and educated female labor force (% of population) in Cyprus in 2002 to that in 2009?
Your answer should be very brief. 1.09. What is the ratio of the Unemployed and educated female labor force (% of population) in Latvia in 2002 to that in 2009?
Your answer should be compact. 1.07. What is the ratio of the Unemployed and educated female labor force (% of population) in Europe(all income levels) in 2002 to that in 2011?
Provide a succinct answer. 1.08. What is the ratio of the Unemployed and educated female labor force (% of population) in Cyprus in 2002 to that in 2011?
Offer a very short reply. 1.01. What is the ratio of the Unemployed and educated female labor force (% of population) of Latvia in 2002 to that in 2011?
Your answer should be very brief. 1.06. What is the ratio of the Unemployed and educated female labor force (% of population) in Europe(all income levels) in 2002 to that in 2012?
Provide a short and direct response. 1.1. What is the ratio of the Unemployed and educated female labor force (% of population) in Albania in 2002 to that in 2012?
Keep it short and to the point. 1.16. What is the ratio of the Unemployed and educated female labor force (% of population) of Cyprus in 2002 to that in 2012?
Make the answer very short. 1.15. What is the ratio of the Unemployed and educated female labor force (% of population) in Latvia in 2002 to that in 2012?
Keep it short and to the point. 1.07. What is the ratio of the Unemployed and educated female labor force (% of population) in Europe(all income levels) in 2002 to that in 2013?
Ensure brevity in your answer.  1.11. What is the ratio of the Unemployed and educated female labor force (% of population) of Albania in 2002 to that in 2013?
Your answer should be compact. 1.15. What is the ratio of the Unemployed and educated female labor force (% of population) of Cyprus in 2002 to that in 2013?
Offer a terse response. 1.02. What is the ratio of the Unemployed and educated female labor force (% of population) of Latvia in 2002 to that in 2013?
Your answer should be compact. 1.18. What is the ratio of the Unemployed and educated female labor force (% of population) of Europe(all income levels) in 2009 to that in 2011?
Give a very brief answer. 1.01. What is the ratio of the Unemployed and educated female labor force (% of population) of Albania in 2009 to that in 2011?
Give a very brief answer. 0.89. What is the ratio of the Unemployed and educated female labor force (% of population) of Cyprus in 2009 to that in 2011?
Keep it short and to the point. 0.93. What is the ratio of the Unemployed and educated female labor force (% of population) in Latvia in 2009 to that in 2011?
Provide a short and direct response. 0.99. What is the ratio of the Unemployed and educated female labor force (% of population) of Europe(all income levels) in 2009 to that in 2012?
Offer a very short reply. 1.03. What is the ratio of the Unemployed and educated female labor force (% of population) of Cyprus in 2009 to that in 2012?
Offer a very short reply. 1.05. What is the ratio of the Unemployed and educated female labor force (% of population) of Europe(all income levels) in 2009 to that in 2013?
Offer a very short reply. 1.04. What is the ratio of the Unemployed and educated female labor force (% of population) of Albania in 2009 to that in 2013?
Your answer should be very brief. 1.03. What is the ratio of the Unemployed and educated female labor force (% of population) of Cyprus in 2009 to that in 2013?
Keep it short and to the point. 0.94. What is the ratio of the Unemployed and educated female labor force (% of population) of Europe(all income levels) in 2011 to that in 2012?
Keep it short and to the point. 1.02. What is the ratio of the Unemployed and educated female labor force (% of population) of Albania in 2011 to that in 2012?
Your answer should be compact. 1.17. What is the ratio of the Unemployed and educated female labor force (% of population) of Cyprus in 2011 to that in 2012?
Ensure brevity in your answer.  1.14. What is the ratio of the Unemployed and educated female labor force (% of population) of Latvia in 2011 to that in 2012?
Offer a very short reply. 1.01. What is the ratio of the Unemployed and educated female labor force (% of population) in Europe(all income levels) in 2011 to that in 2013?
Offer a very short reply. 1.03. What is the ratio of the Unemployed and educated female labor force (% of population) of Albania in 2011 to that in 2013?
Your answer should be compact. 1.17. What is the ratio of the Unemployed and educated female labor force (% of population) in Cyprus in 2011 to that in 2013?
Make the answer very short. 1.01. What is the ratio of the Unemployed and educated female labor force (% of population) in Latvia in 2011 to that in 2013?
Your response must be concise. 1.11. What is the ratio of the Unemployed and educated female labor force (% of population) in Europe(all income levels) in 2012 to that in 2013?
Your response must be concise. 1.01. What is the ratio of the Unemployed and educated female labor force (% of population) in Cyprus in 2012 to that in 2013?
Ensure brevity in your answer.  0.89. What is the ratio of the Unemployed and educated female labor force (% of population) in Latvia in 2012 to that in 2013?
Make the answer very short. 1.1. What is the difference between the highest and the second highest Unemployed and educated female labor force (% of population) of Europe(all income levels)?
Your response must be concise. 0.82. What is the difference between the highest and the second highest Unemployed and educated female labor force (% of population) in Albania?
Your answer should be very brief. 6.2. What is the difference between the highest and the second highest Unemployed and educated female labor force (% of population) in Cyprus?
Provide a short and direct response. 0.8. What is the difference between the highest and the second highest Unemployed and educated female labor force (% of population) in Latvia?
Keep it short and to the point. 6.4. What is the difference between the highest and the lowest Unemployed and educated female labor force (% of population) in Europe(all income levels)?
Your answer should be compact. 6.02. 